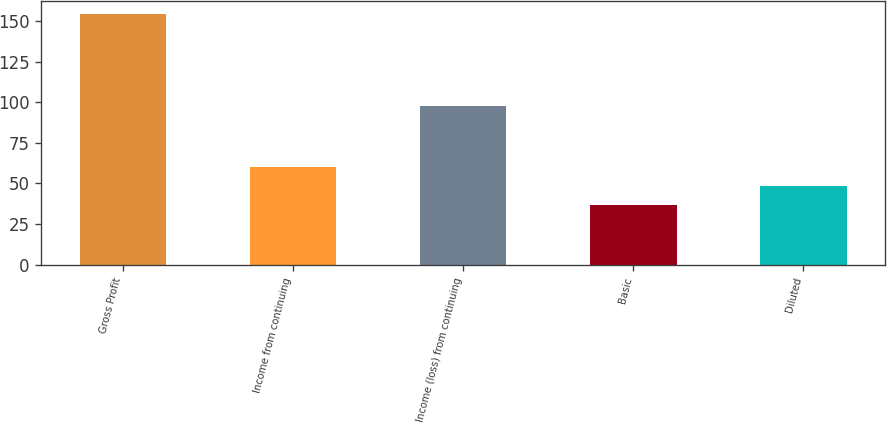Convert chart to OTSL. <chart><loc_0><loc_0><loc_500><loc_500><bar_chart><fcel>Gross Profit<fcel>Income from continuing<fcel>Income (loss) from continuing<fcel>Basic<fcel>Diluted<nl><fcel>154.4<fcel>60.32<fcel>97.4<fcel>36.8<fcel>48.56<nl></chart> 